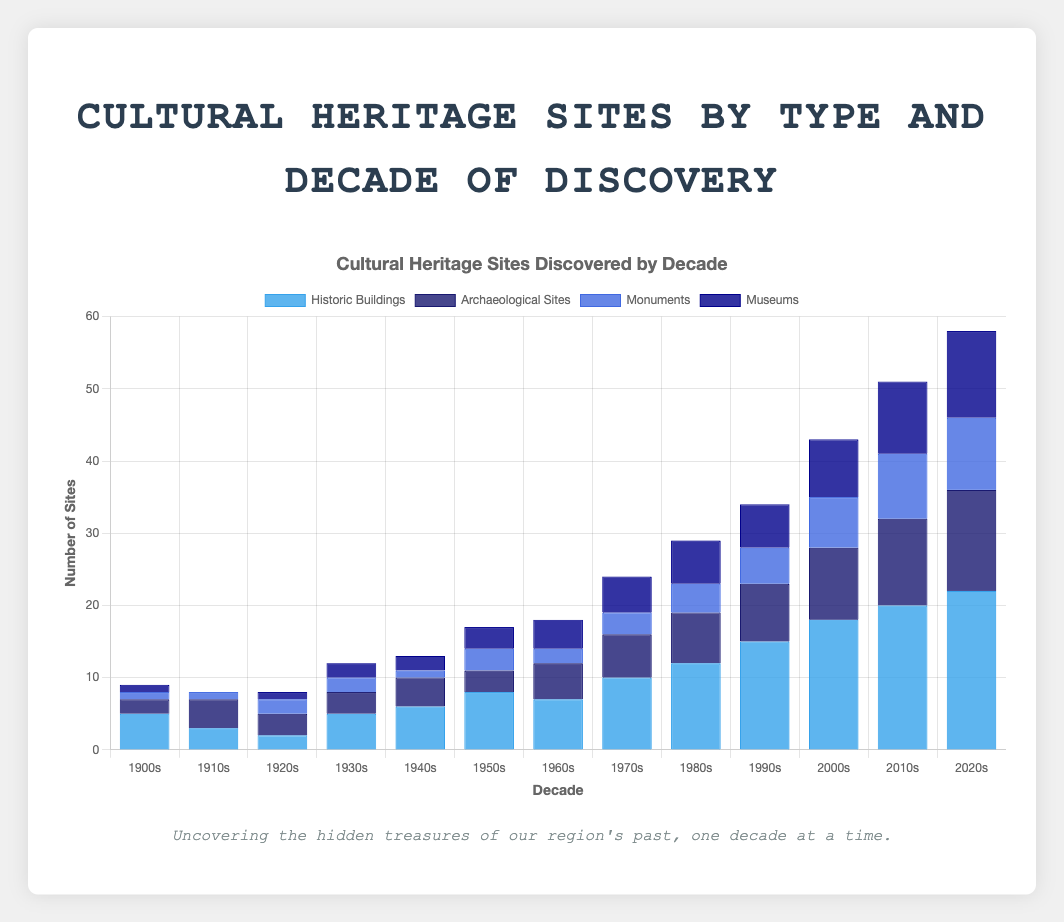Which decade saw the highest number of Historic Buildings discovered? By visually inspecting the height of the bars representing 'Historic Buildings' across the decades, the bar for the 2020s is the tallest.
Answer: 2020s Which decade had more Archaeological Sites discovered: the 1910s or the 1920s? Compare the bar heights for 'Archaeological Sites' between the 1910s and the 1920s. The bar for the 1910s is taller.
Answer: 1910s What is the total number of Monuments discovered from the 1900s to the 1930s? Sum up the values of 'Monuments' for the decades 1900s, 1910s, 1920s, and 1930s: 1 + 1 + 2 + 2 = 6.
Answer: 6 In which decade were there more Museums discovered than in the 1950s? Compare the heights of the 'Museums' bars in each decade to the 1950s. Decades with taller bars are the 1960s (4), 1970s (5), 1980s (6), 1990s (6), 2000s (8), 2010s (10), and 2020s (12).
Answer: 1960s, 1970s, 1980s, 1990s, 2000s, 2010s, and 2020s Compare the number of total sites (all types) discovered in the 1900s and the 1960s. Which decade had more discoveries? Add up the values for all site types in the 1900s (5 + 2 + 1 + 1 = 9) and the 1960s (7 + 5 + 2 + 4 = 18) and compare.
Answer: 1960s What is the difference in the number of Historic Buildings discovered between the 1980s and the 2000s? Subtract the value for 'Historic Buildings' in the 1980s (12) from the value in the 2000s (18): 18 - 12 = 6.
Answer: 6 How many more Archaeological Sites were discovered in the 2010s compared to the 2000s? Subtract the value for 'Archaeological Sites' in the 2000s (10) from the value in the 2010s (12): 12 - 10 = 2.
Answer: 2 Which type of site had the smallest total discoveries in the 1900s? By visually comparing the bar lengths for each site type in the 1900s, the shortest bar is for both 'Monuments' and 'Museums' with equal smallest values.
Answer: Monuments and Museums What is the average number of Historic Buildings discovered per decade? Sum the values for 'Historic Buildings' across all decades (5 + 3 + 2 + 5 + 6 + 8 + 7 + 10 + 12 + 15 + 18 + 20 + 22 = 133) and divide by the number of decades (13): 133 / 13 ≈ 10.23.
Answer: 10.23 